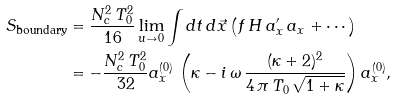<formula> <loc_0><loc_0><loc_500><loc_500>S _ { \text {boundary} } & = \frac { N _ { c } ^ { 2 } \, T _ { 0 } ^ { 2 } } { 1 6 } \lim _ { u \to 0 } \int d t \, d \vec { x } \left ( f \, H \, a _ { x } ^ { \prime } \, a _ { x } + \cdots \right ) \\ & = - \frac { N _ { c } ^ { 2 } \, T _ { 0 } ^ { 2 } } { 3 2 } a _ { x } ^ { ( 0 ) } \, \left ( \kappa - i \, \omega \, \frac { ( \kappa + 2 ) ^ { 2 } } { 4 \, \pi \, T _ { 0 } \, \sqrt { 1 + \kappa } } \right ) a _ { x } ^ { ( 0 ) } ,</formula> 